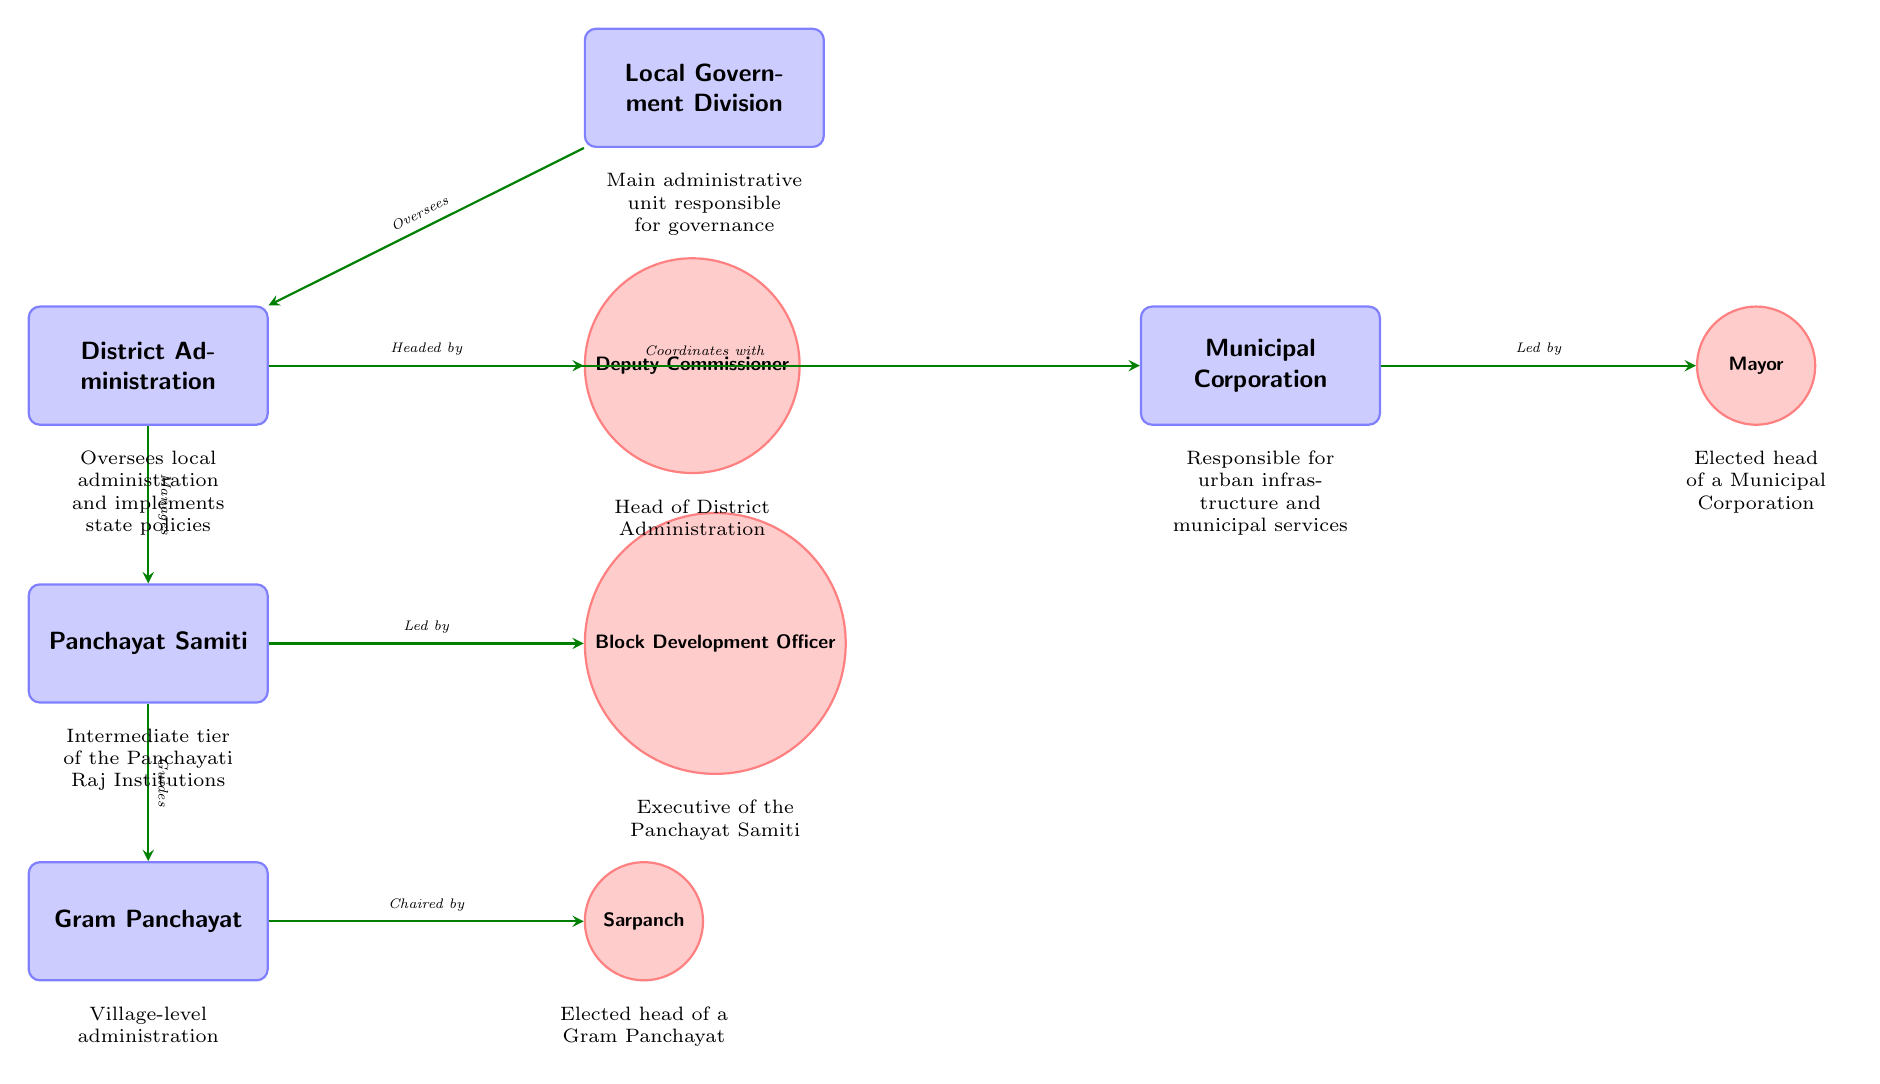What is the main administrative unit responsible for governance? The diagram highlights "Local Government Division" as the main administrative unit, indicated clearly at the top of the hierarchy.
Answer: Local Government Division How many key local governmental units are represented in the diagram? By counting the boxes that represent distinct units, we identify five key local governmental units: Local Government Division, District Administration, Municipal Corporation, Panchayat Samiti, and Gram Panchayat.
Answer: 5 Who oversees the District Administration? The arrow directed from "Local Government Division" to "District Administration" labeled "Oversees" indicates that the Local Government Division is responsible for overseeing the District Administration.
Answer: Local Government Division What role is responsible for managing the Panchayat Samiti? The diagram shows that the "District Administration" is managing the "Panchayat Samiti," as identified in the arrow labeled "Manages" leading from the District Administration to the Panchayat Samiti.
Answer: District Administration Which role is led by the Mayor? The direct relationship indicated by the arrow from "Municipal Corporation" to "Mayor" is labeled "Led by," showing that the role led by the Mayor is within the Municipal Corporation.
Answer: Mayor If we wanted to know the hierarchy of roles within the Panchayat Samiti, which role comes before the Sarpanch? By following the lines downward, we see that the "Panchayat Samiti" leads to the "Gram Panchayat," and the "Sarpanch" is in charge at the Gram Panchayat level, indicating that the BDO comes before the Sarpanch in the hierarchy.
Answer: Block Development Officer How does the District Administration coordinate with the Municipal Corporation? The relationship is depicted by the arrow between "District Administration" and "Municipal Corporation," labeled "Coordinates with," which describes the cooperative interaction between these two units.
Answer: Coordinates with What is the role of the Deputy Commissioner? The diagram distinctly labels the "Deputy Commissioner" as the head of the District Administration, linked by the phrase "Headed by" in the respective arrow, indicating that this is the primary responsibility of the Deputy Commissioner.
Answer: Head of District Administration 